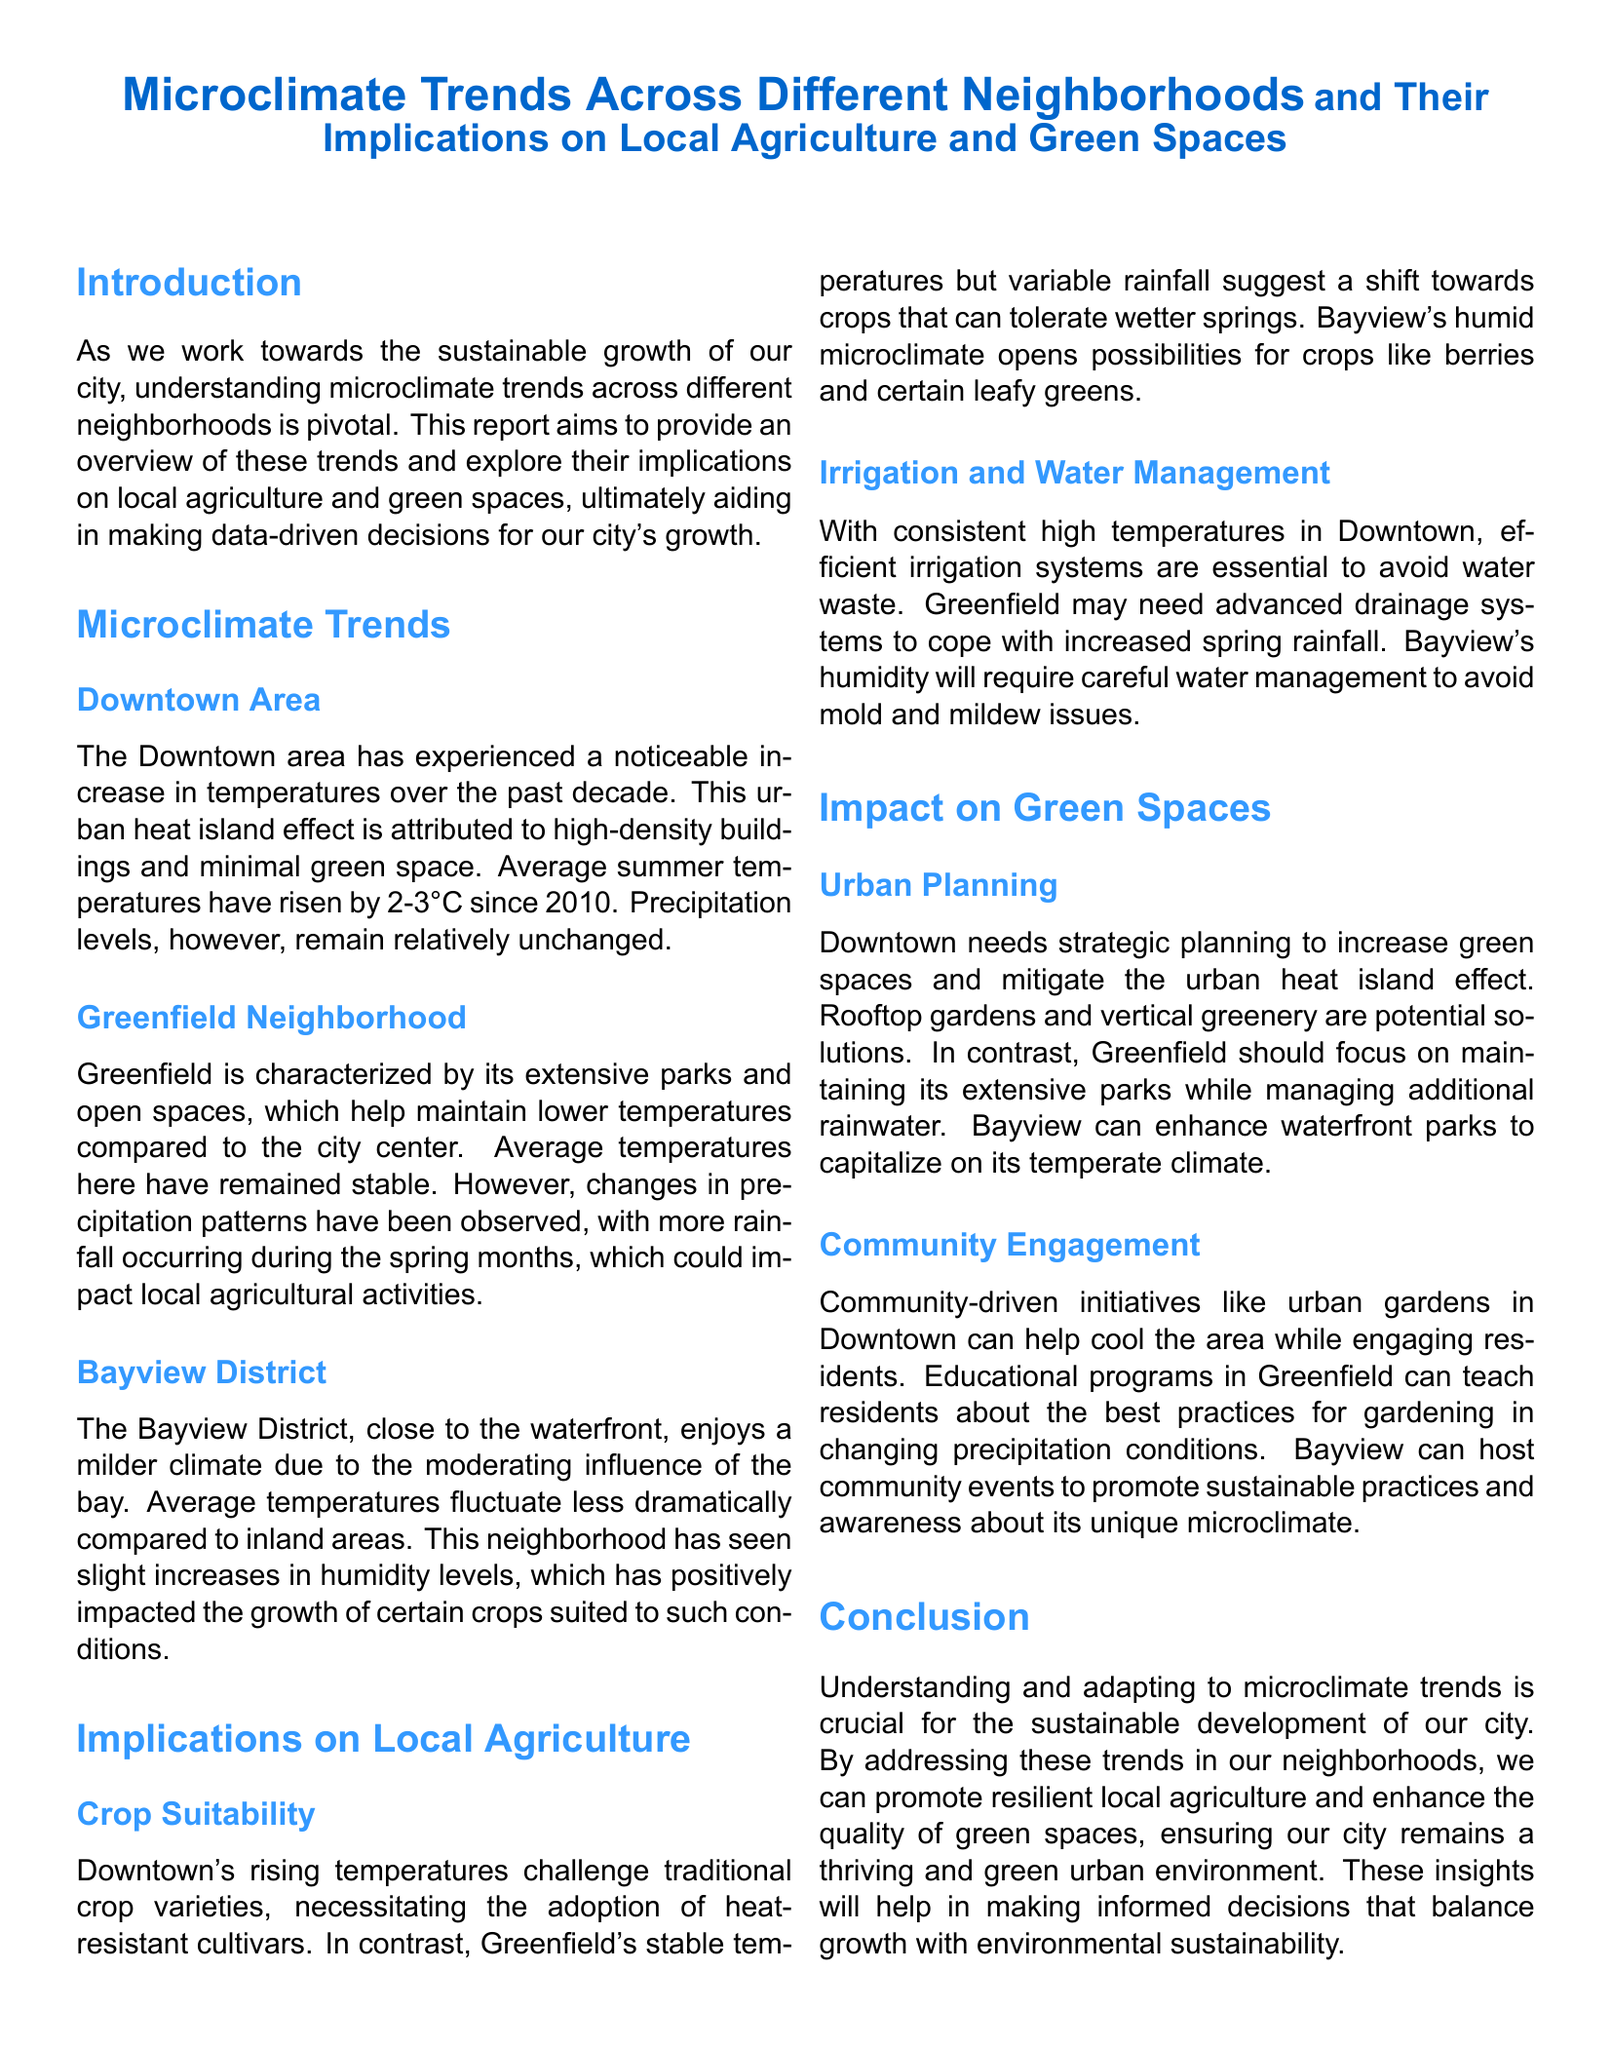What is the average temperature increase in Downtown since 2010? The report states that average summer temperatures have risen by 2-3°C since 2010 in the Downtown area.
Answer: 2-3°C What neighborhood has stable average temperatures? The document mentions that Greenfield is characterized by its stable average temperatures.
Answer: Greenfield Which crops could thrive in Bayview due to humidity? The report indicates that the humid microclimate in Bayview opens possibilities for crops like berries and certain leafy greens.
Answer: Berries and leafy greens What type of irrigation system is necessary for Downtown? The document emphasizes that efficient irrigation systems are essential in Downtown due to consistent high temperatures.
Answer: Efficient irrigation systems How should Greenfield manage increased spring rainfall? The report suggests that Greenfield may need advanced drainage systems to cope with increased spring rainfall.
Answer: Advanced drainage systems What urban planning solution is proposed for Downtown? The document suggests that Downtown needs strategic planning to increase green spaces, such as rooftop gardens and vertical greenery.
Answer: Rooftop gardens and vertical greenery What is the role of community-driven initiatives in Downtown? The report states that community-driven initiatives like urban gardens can help cool the area while engaging residents.
Answer: Cool the area and engage residents What educational program is suggested for Greenfield? The document proposes educational programs in Greenfield to teach residents about gardening practices in changing precipitation conditions.
Answer: Gardening practices 